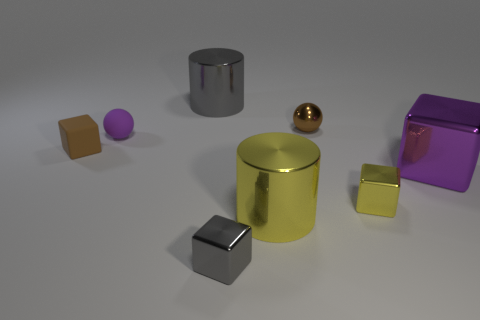What is the shape of the tiny thing that is both in front of the rubber cube and behind the gray cube?
Your answer should be compact. Cube. There is a cylinder right of the large cylinder behind the small brown matte cube; what size is it?
Make the answer very short. Large. What number of yellow shiny things have the same shape as the large gray metallic thing?
Give a very brief answer. 1. Does the tiny rubber cube have the same color as the metal sphere?
Give a very brief answer. Yes. Is there a metal object of the same color as the small rubber cube?
Make the answer very short. Yes. Are the tiny cube that is behind the purple shiny block and the purple thing in front of the small purple thing made of the same material?
Keep it short and to the point. No. The big shiny cube has what color?
Provide a succinct answer. Purple. There is a cylinder in front of the tiny brown thing right of the big metal cylinder that is in front of the large purple metallic cube; how big is it?
Offer a terse response. Large. How many other things are the same size as the brown rubber object?
Your response must be concise. 4. How many large blocks have the same material as the purple ball?
Keep it short and to the point. 0. 